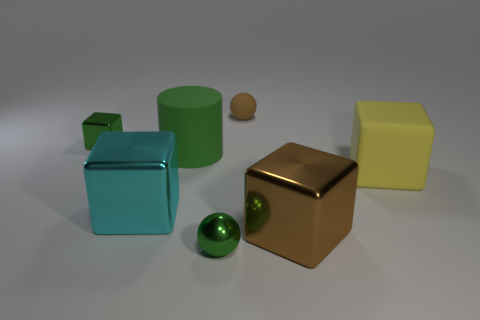The ball that is the same material as the green cube is what size?
Give a very brief answer. Small. What number of tiny brown rubber objects are to the left of the tiny shiny thing that is on the right side of the large green rubber object?
Your response must be concise. 0. Is the large brown metal object the same shape as the cyan metal object?
Your answer should be compact. Yes. Are there any other things of the same color as the tiny rubber ball?
Give a very brief answer. Yes. There is a big yellow thing; is it the same shape as the metallic object behind the large matte cube?
Offer a very short reply. Yes. There is a big shiny block that is right of the sphere in front of the green metallic object behind the matte cube; what color is it?
Your response must be concise. Brown. There is a green thing that is on the left side of the big cyan shiny object; does it have the same shape as the yellow rubber object?
Make the answer very short. Yes. What material is the small brown sphere?
Make the answer very short. Rubber. The green shiny thing to the right of the green metal thing behind the ball in front of the yellow matte cube is what shape?
Keep it short and to the point. Sphere. What number of other things are the same shape as the big yellow object?
Your response must be concise. 3. 